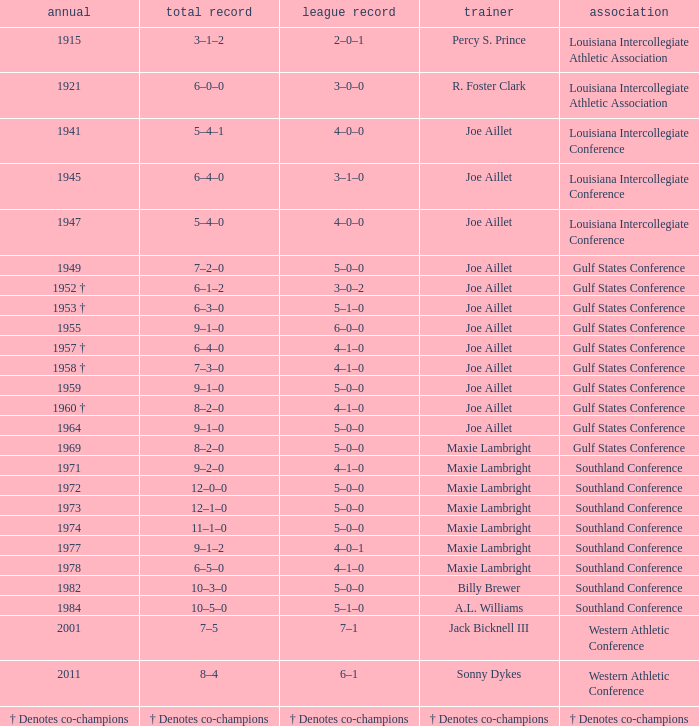What is the conference record for the year of 1971? 4–1–0. 